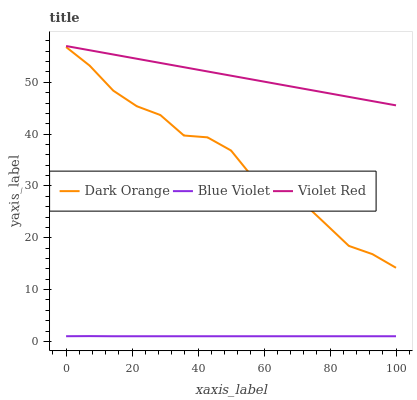Does Blue Violet have the minimum area under the curve?
Answer yes or no. Yes. Does Violet Red have the maximum area under the curve?
Answer yes or no. Yes. Does Violet Red have the minimum area under the curve?
Answer yes or no. No. Does Blue Violet have the maximum area under the curve?
Answer yes or no. No. Is Violet Red the smoothest?
Answer yes or no. Yes. Is Dark Orange the roughest?
Answer yes or no. Yes. Is Blue Violet the smoothest?
Answer yes or no. No. Is Blue Violet the roughest?
Answer yes or no. No. Does Violet Red have the lowest value?
Answer yes or no. No. Does Violet Red have the highest value?
Answer yes or no. Yes. Does Blue Violet have the highest value?
Answer yes or no. No. Is Blue Violet less than Violet Red?
Answer yes or no. Yes. Is Violet Red greater than Blue Violet?
Answer yes or no. Yes. Does Blue Violet intersect Violet Red?
Answer yes or no. No. 